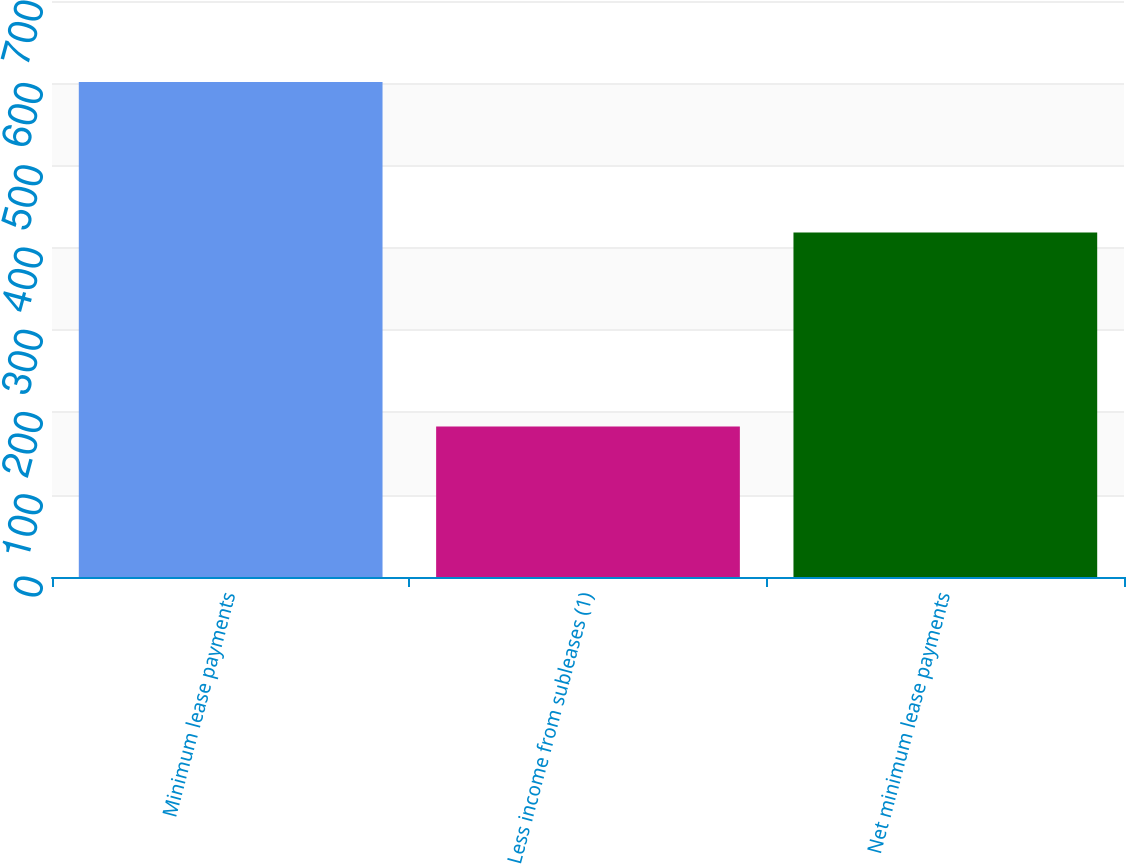Convert chart to OTSL. <chart><loc_0><loc_0><loc_500><loc_500><bar_chart><fcel>Minimum lease payments<fcel>Less income from subleases (1)<fcel>Net minimum lease payments<nl><fcel>601.6<fcel>182.8<fcel>418.8<nl></chart> 